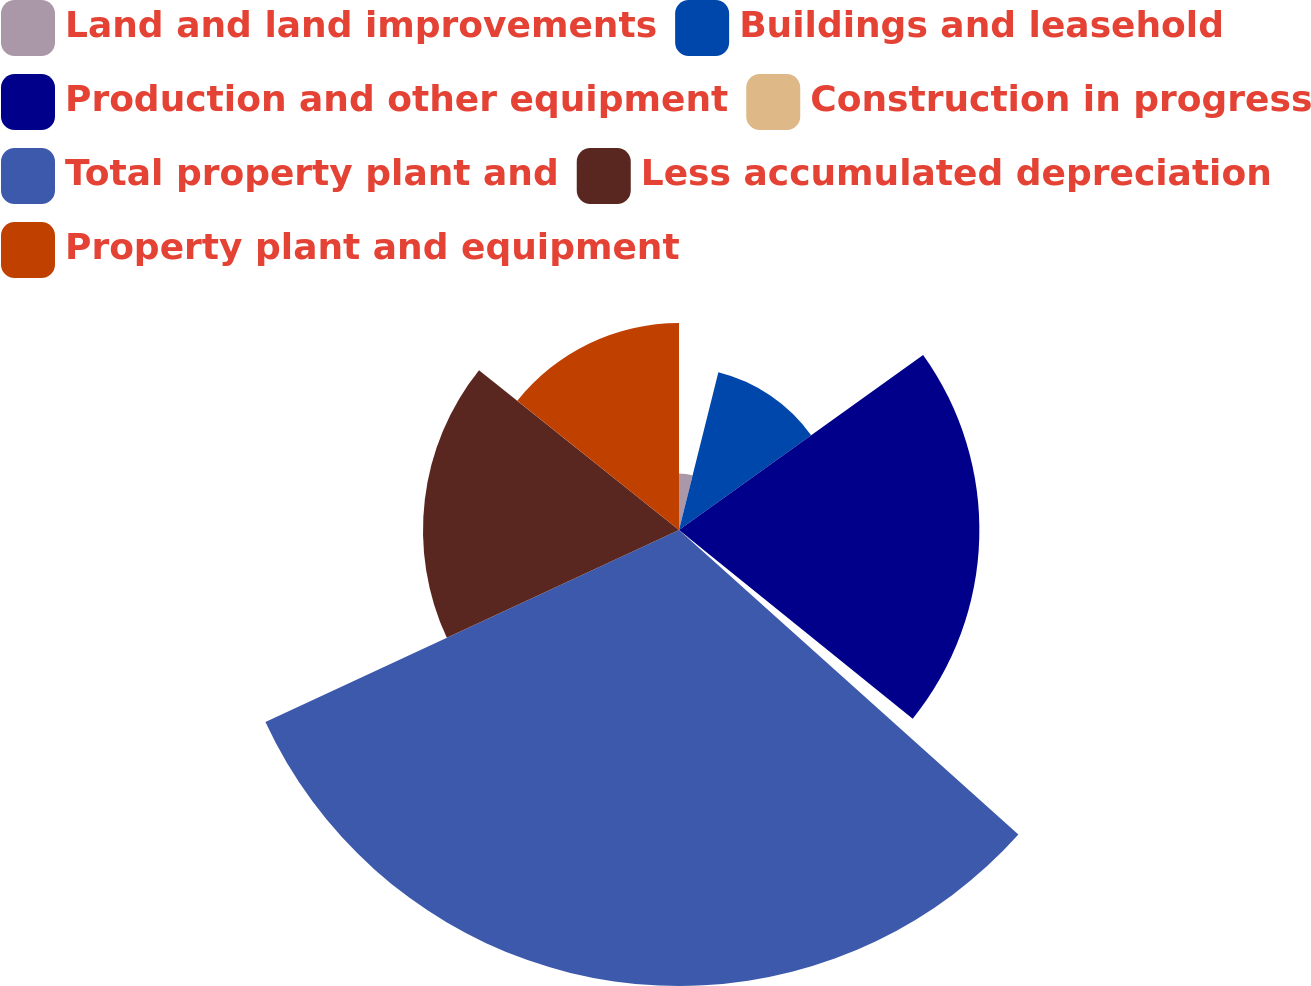<chart> <loc_0><loc_0><loc_500><loc_500><pie_chart><fcel>Land and land improvements<fcel>Buildings and leasehold<fcel>Production and other equipment<fcel>Construction in progress<fcel>Total property plant and<fcel>Less accumulated depreciation<fcel>Property plant and equipment<nl><fcel>3.89%<fcel>11.21%<fcel>20.71%<fcel>0.83%<fcel>31.44%<fcel>17.65%<fcel>14.27%<nl></chart> 